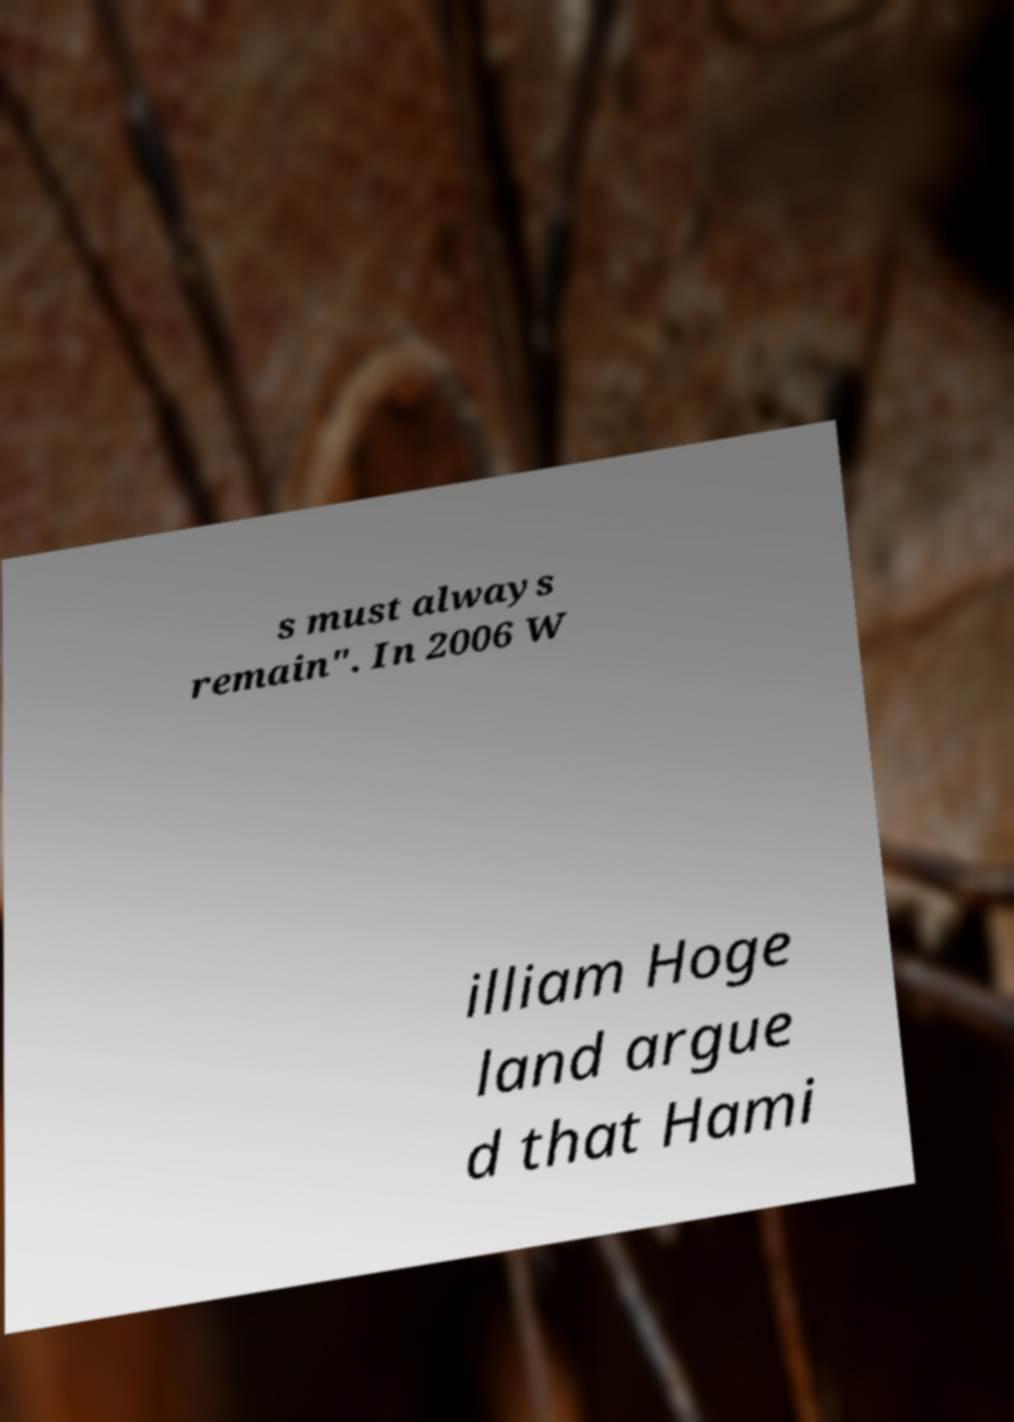Please read and relay the text visible in this image. What does it say? s must always remain". In 2006 W illiam Hoge land argue d that Hami 